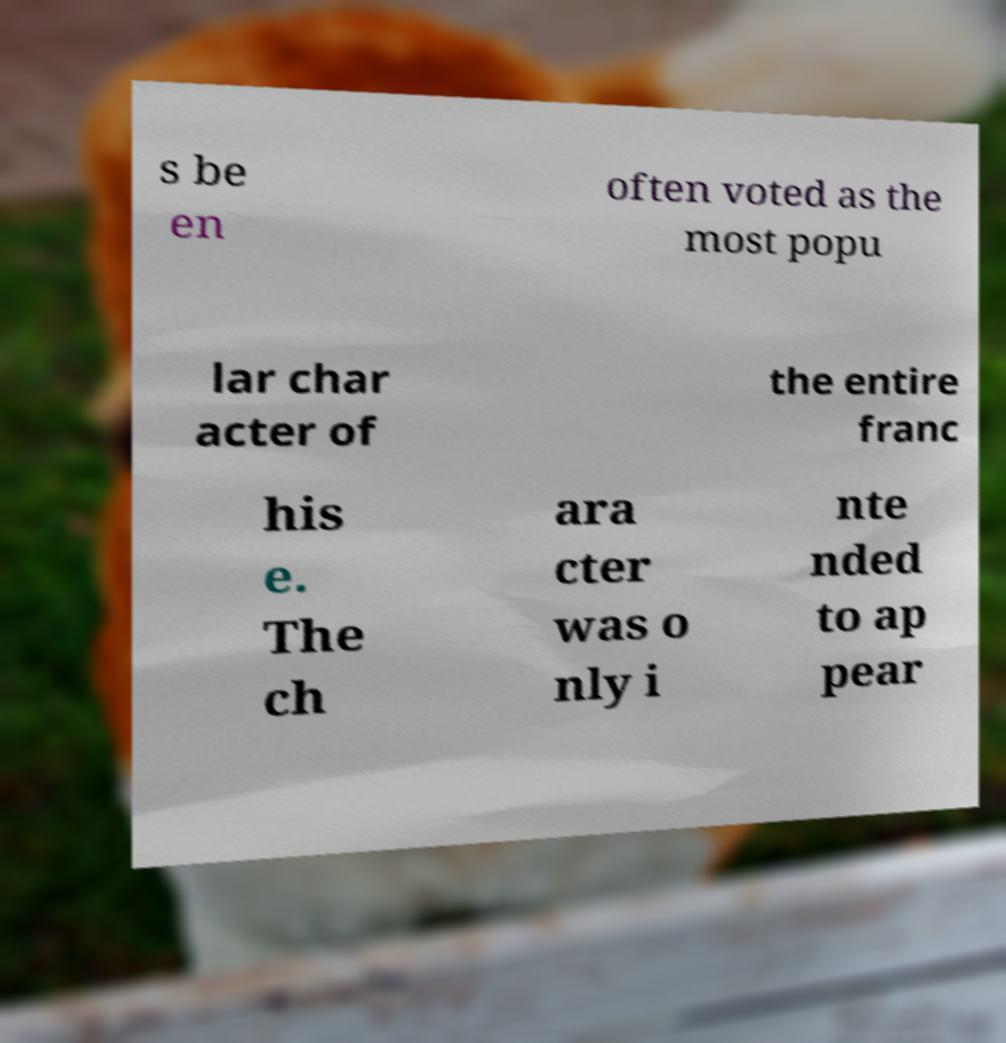Can you accurately transcribe the text from the provided image for me? s be en often voted as the most popu lar char acter of the entire franc his e. The ch ara cter was o nly i nte nded to ap pear 